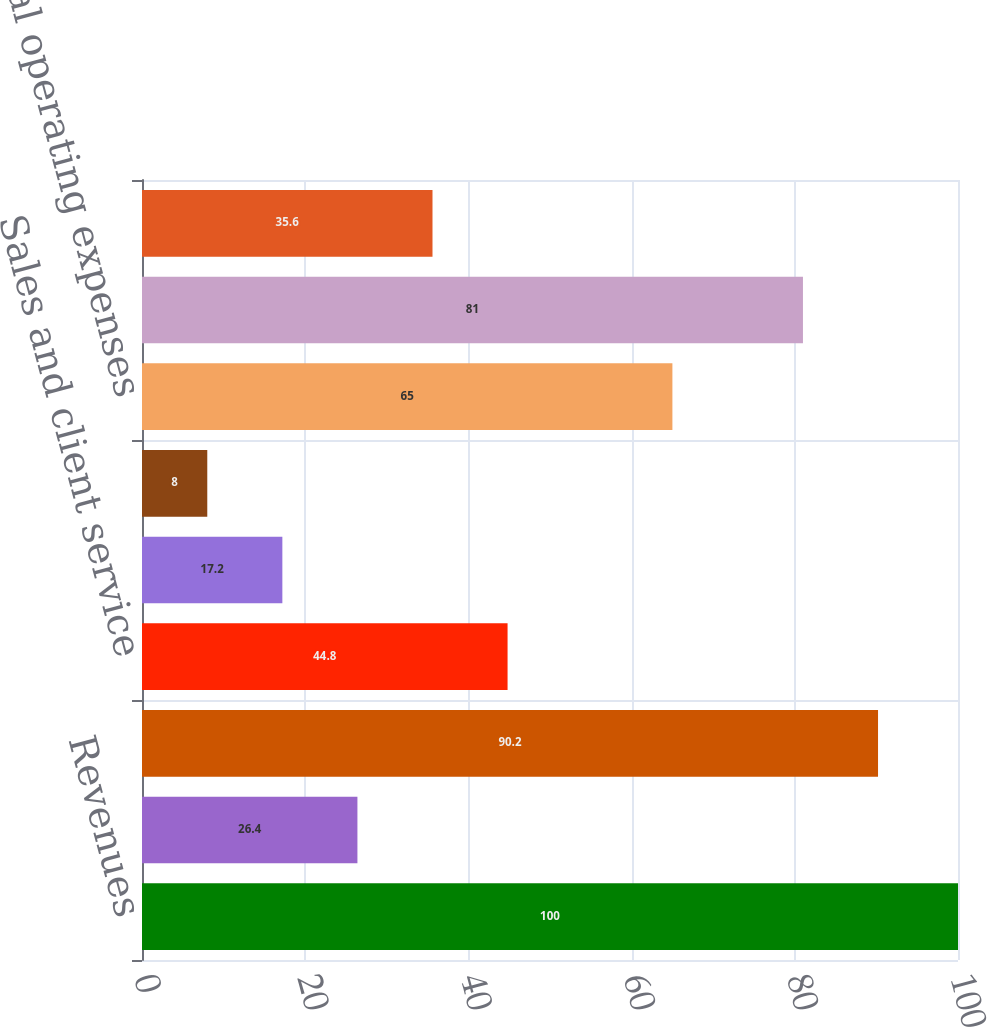<chart> <loc_0><loc_0><loc_500><loc_500><bar_chart><fcel>Revenues<fcel>Costs of revenue<fcel>Margin<fcel>Sales and client service<fcel>Software development<fcel>General and administrative<fcel>Total operating expenses<fcel>Total costs and expenses<fcel>Operating earnings<nl><fcel>100<fcel>26.4<fcel>90.2<fcel>44.8<fcel>17.2<fcel>8<fcel>65<fcel>81<fcel>35.6<nl></chart> 